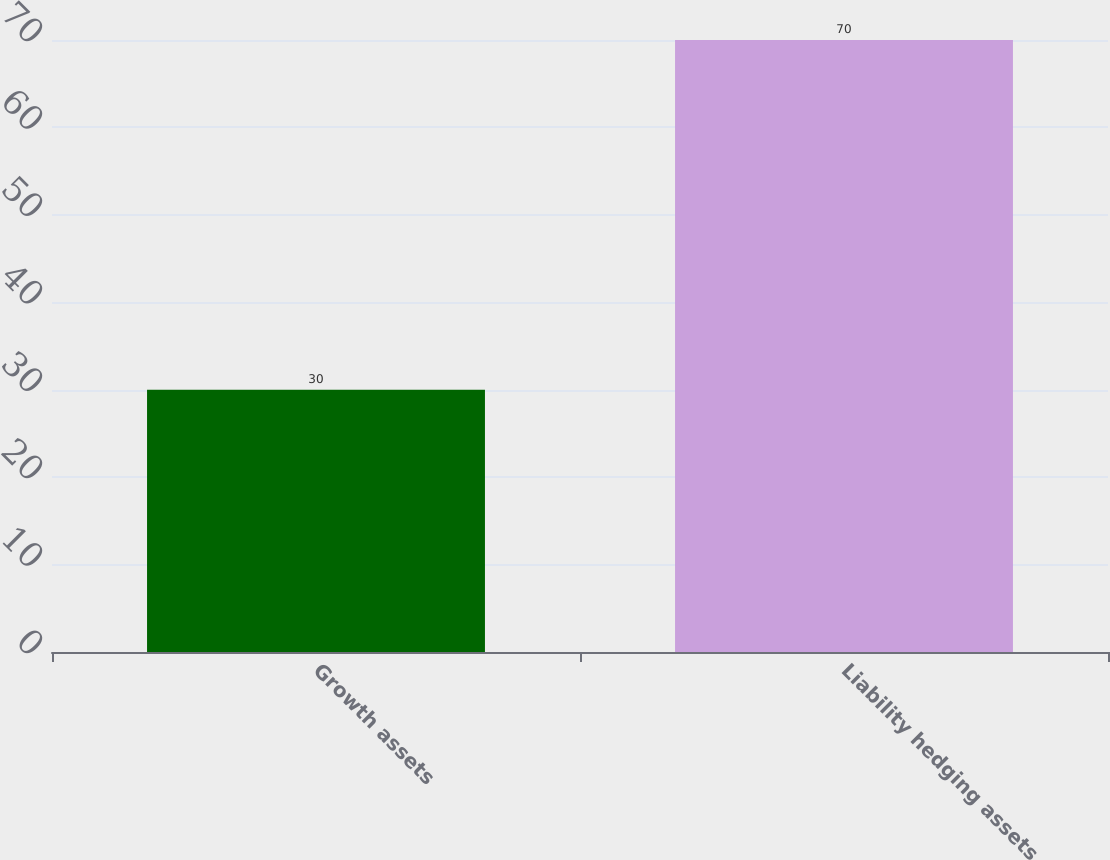Convert chart. <chart><loc_0><loc_0><loc_500><loc_500><bar_chart><fcel>Growth assets<fcel>Liability hedging assets<nl><fcel>30<fcel>70<nl></chart> 